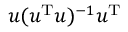Convert formula to latex. <formula><loc_0><loc_0><loc_500><loc_500>u ( u ^ { T } u ) ^ { - 1 } u ^ { T }</formula> 